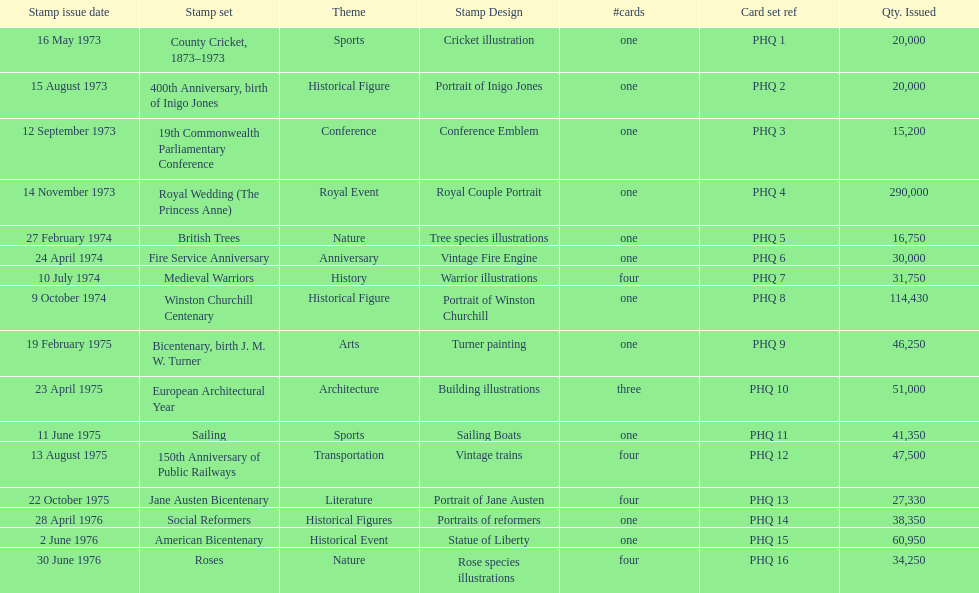Which card was issued most? Royal Wedding (The Princess Anne). 